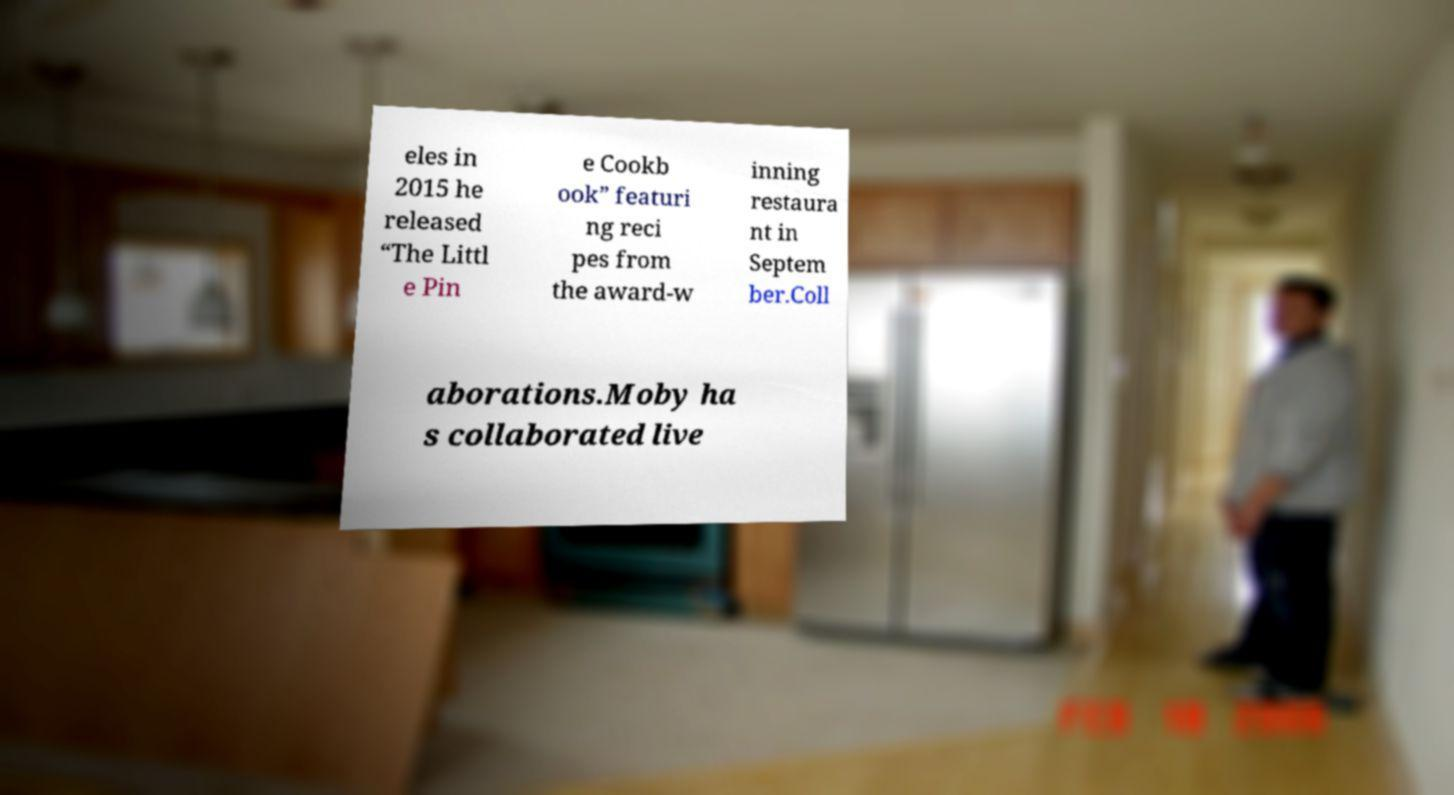Can you read and provide the text displayed in the image?This photo seems to have some interesting text. Can you extract and type it out for me? eles in 2015 he released “The Littl e Pin e Cookb ook” featuri ng reci pes from the award-w inning restaura nt in Septem ber.Coll aborations.Moby ha s collaborated live 